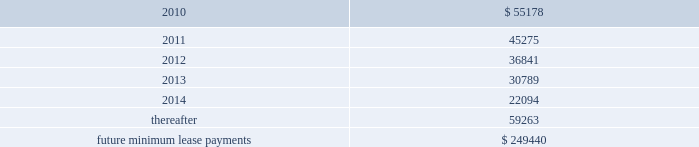Note 9 .
Commitments and contingencies operating leases we are obligated under noncancelable operating leases for corporate office space , warehouse and distribution facilities , trucks and certain equipment .
The future minimum lease commitments under these leases at december 31 , 2009 are as follows ( in thousands ) : years ending december 31: .
Rental expense for operating leases was approximately $ 57.2 million , $ 49.0 million and $ 26.6 million during the years ended december 31 , 2009 , 2008 and 2007 , respectively .
We guarantee the residual values of the majority of our truck and equipment operating leases .
The residual values decline over the lease terms to a defined percentage of original cost .
In the event the lessor does not realize the residual value when a piece of equipment is sold , we would be responsible for a portion of the shortfall .
Similarly , if the lessor realizes more than the residual value when a piece of equipment is sold , we would be paid the amount realized over the residual value .
Had we terminated all of our operating leases subject to these guarantees at december 31 , 2009 , the guaranteed residual value would have totaled approximately $ 27.8 million .
Litigation and related contingencies in december 2005 and may 2008 , ford global technologies , llc filed complaints with the international trade commission against us and others alleging that certain aftermarket parts imported into the u.s .
Infringed on ford design patents .
The parties settled these matters in april 2009 pursuant to a settlement arrangement that expires in september 2011 .
Pursuant to the settlement , we ( and our designees ) became the sole distributor in the united states of aftermarket automotive parts that correspond to ford collision parts that are covered by a united states design patent .
We have paid ford an upfront fee for these rights and will pay a royalty for each such part we sell .
The amortization of the upfront fee and the royalty expenses are reflected in cost of goods sold on the accompanying consolidated statements of income .
We also have certain other contingencies resulting from litigation , claims and other commitments and are subject to a variety of environmental and pollution control laws and regulations incident to the ordinary course of business .
We currently expect that the resolution of such contingencies will not materially affect our financial position , results of operations or cash flows .
Note 10 .
Business combinations on october 1 , 2009 , we acquired greenleaf auto recyclers , llc ( 201cgreenleaf 201d ) from ssi for $ 38.8 million , net of cash acquired .
Greenleaf is the entity through which ssi operated its late model automotive parts recycling business .
We recorded a gain on bargain purchase for the greenleaf acquisition totaling $ 4.3 million , which is .
What was the percentage change in rental expense for operating leases from 2008 to 2009? 
Computations: ((57.2 - 49.0) / 49.0)
Answer: 0.16735. Note 9 .
Commitments and contingencies operating leases we are obligated under noncancelable operating leases for corporate office space , warehouse and distribution facilities , trucks and certain equipment .
The future minimum lease commitments under these leases at december 31 , 2009 are as follows ( in thousands ) : years ending december 31: .
Rental expense for operating leases was approximately $ 57.2 million , $ 49.0 million and $ 26.6 million during the years ended december 31 , 2009 , 2008 and 2007 , respectively .
We guarantee the residual values of the majority of our truck and equipment operating leases .
The residual values decline over the lease terms to a defined percentage of original cost .
In the event the lessor does not realize the residual value when a piece of equipment is sold , we would be responsible for a portion of the shortfall .
Similarly , if the lessor realizes more than the residual value when a piece of equipment is sold , we would be paid the amount realized over the residual value .
Had we terminated all of our operating leases subject to these guarantees at december 31 , 2009 , the guaranteed residual value would have totaled approximately $ 27.8 million .
Litigation and related contingencies in december 2005 and may 2008 , ford global technologies , llc filed complaints with the international trade commission against us and others alleging that certain aftermarket parts imported into the u.s .
Infringed on ford design patents .
The parties settled these matters in april 2009 pursuant to a settlement arrangement that expires in september 2011 .
Pursuant to the settlement , we ( and our designees ) became the sole distributor in the united states of aftermarket automotive parts that correspond to ford collision parts that are covered by a united states design patent .
We have paid ford an upfront fee for these rights and will pay a royalty for each such part we sell .
The amortization of the upfront fee and the royalty expenses are reflected in cost of goods sold on the accompanying consolidated statements of income .
We also have certain other contingencies resulting from litigation , claims and other commitments and are subject to a variety of environmental and pollution control laws and regulations incident to the ordinary course of business .
We currently expect that the resolution of such contingencies will not materially affect our financial position , results of operations or cash flows .
Note 10 .
Business combinations on october 1 , 2009 , we acquired greenleaf auto recyclers , llc ( 201cgreenleaf 201d ) from ssi for $ 38.8 million , net of cash acquired .
Greenleaf is the entity through which ssi operated its late model automotive parts recycling business .
We recorded a gain on bargain purchase for the greenleaf acquisition totaling $ 4.3 million , which is .
In 2009 what was the percent of the total future minimum lease commitments and contingencies for operating leases that was due in 2012? 
Computations: (36841 / 249440)
Answer: 0.14769. 